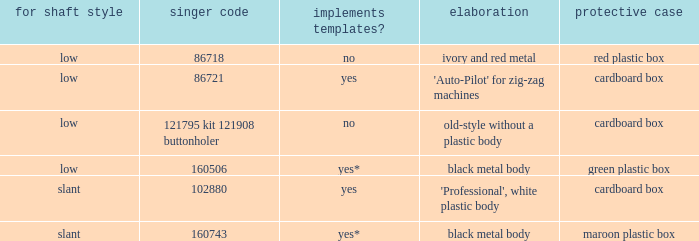What's the singer part number of the buttonholer whose storage case is a green plastic box? 160506.0. 